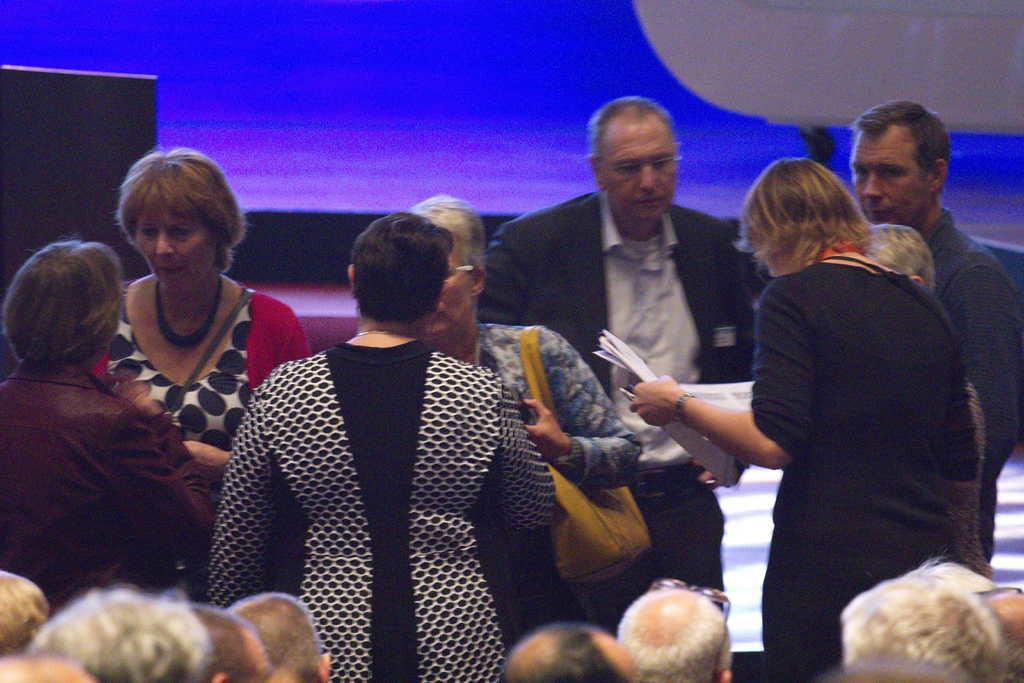What is present in the image? There are people standing in the image. Can you describe any specific features of the people in the image? The heads of some people are visible in the image. What type of horn can be seen on the heads of the people in the image? There is no horn present on the heads of the people in the image. What type of animal, such as a giraffe, can be seen among the people in the image? There is no giraffe or any other animal present among the people in the image. 